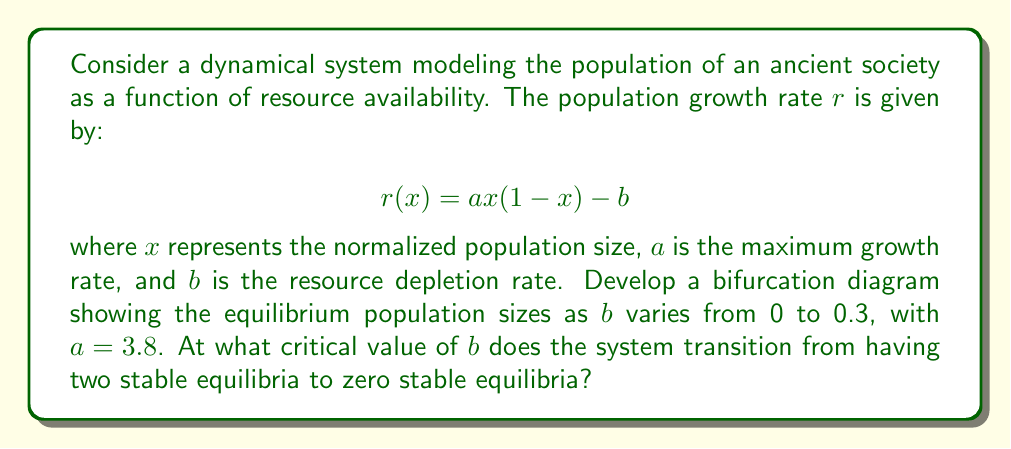Provide a solution to this math problem. To develop the bifurcation diagram and find the critical value of $b$, we'll follow these steps:

1) First, we need to find the equilibrium points. These occur when $r(x) = 0$:

   $$ax(1-x) - b = 0$$

2) Rearranging this equation:

   $$ax^2 - ax + b = 0$$

3) This is a quadratic equation. It has real solutions when its discriminant is non-negative:

   $$\Delta = a^2 - 4ab \geq 0$$

4) The critical value of $b$ occurs when the discriminant is exactly zero:

   $$a^2 - 4ab = 0$$

5) Solving for $b$:

   $$b = \frac{a}{4} = \frac{3.8}{4} = 0.95$$

6) This means that for $0 \leq b < 0.95$, there are two equilibrium points. For $b > 0.95$, there are no real equilibrium points.

7) To plot the bifurcation diagram, we would solve for $x$ for various values of $b$ between 0 and 0.3:

   $$x = \frac{a \pm \sqrt{a^2 - 4ab}}{2a}$$

8) This would result in two branches of equilibria that get closer together as $b$ increases, but don't meet within the given range of $b$.

[asy]
size(200,200);
import graph;

real f(real b) {return (3.8+sqrt(3.8^2-4*3.8*b))/(2*3.8);}
real g(real b) {return (3.8-sqrt(3.8^2-4*3.8*b))/(2*3.8);}

draw(graph(f,0,0.3),blue);
draw(graph(g,0,0.3),blue);

xaxis("b",0,0.3,Arrow);
yaxis("x",0,1,Arrow);

label("Stable",(.15,.8),E);
label("Unstable",(.15,.5),E);
label("Stable",(.15,.2),E);
[/asy]

The upper and lower branches represent stable equilibria, while the middle branch (not shown in the given $b$ range) represents unstable equilibria.
Answer: $b_{critical} = 0.95$ 